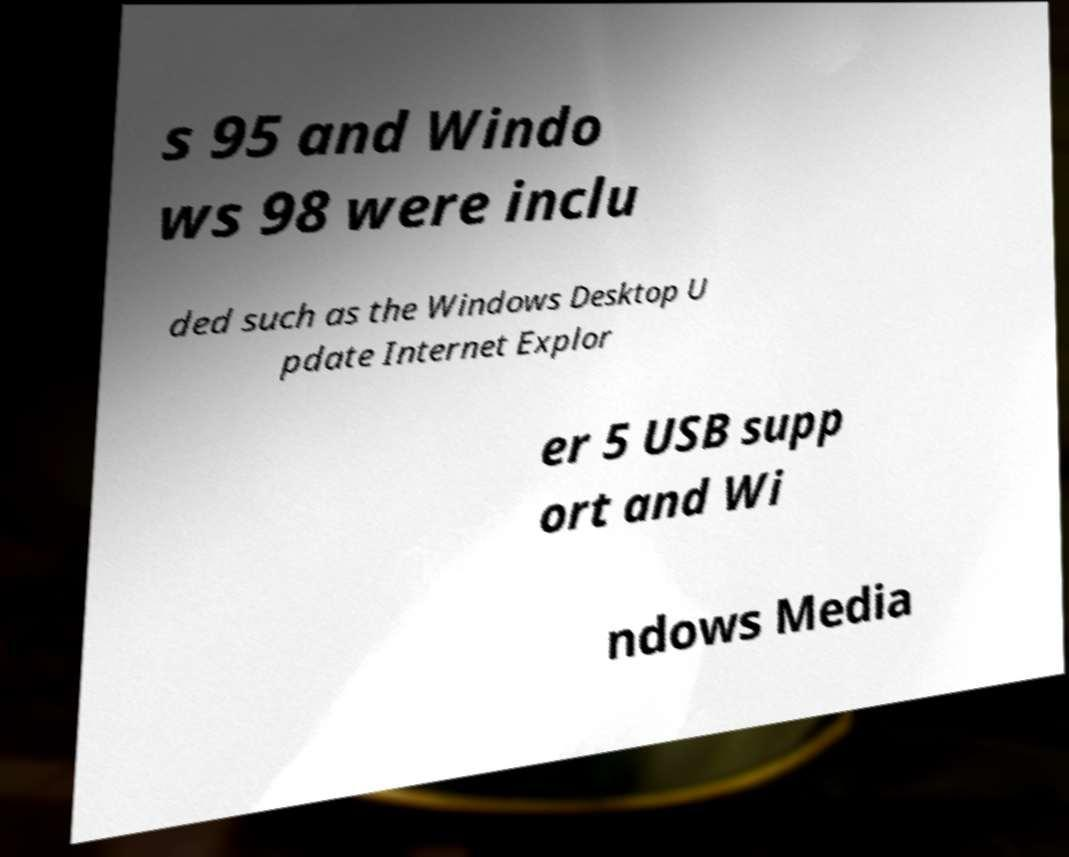Can you read and provide the text displayed in the image?This photo seems to have some interesting text. Can you extract and type it out for me? s 95 and Windo ws 98 were inclu ded such as the Windows Desktop U pdate Internet Explor er 5 USB supp ort and Wi ndows Media 